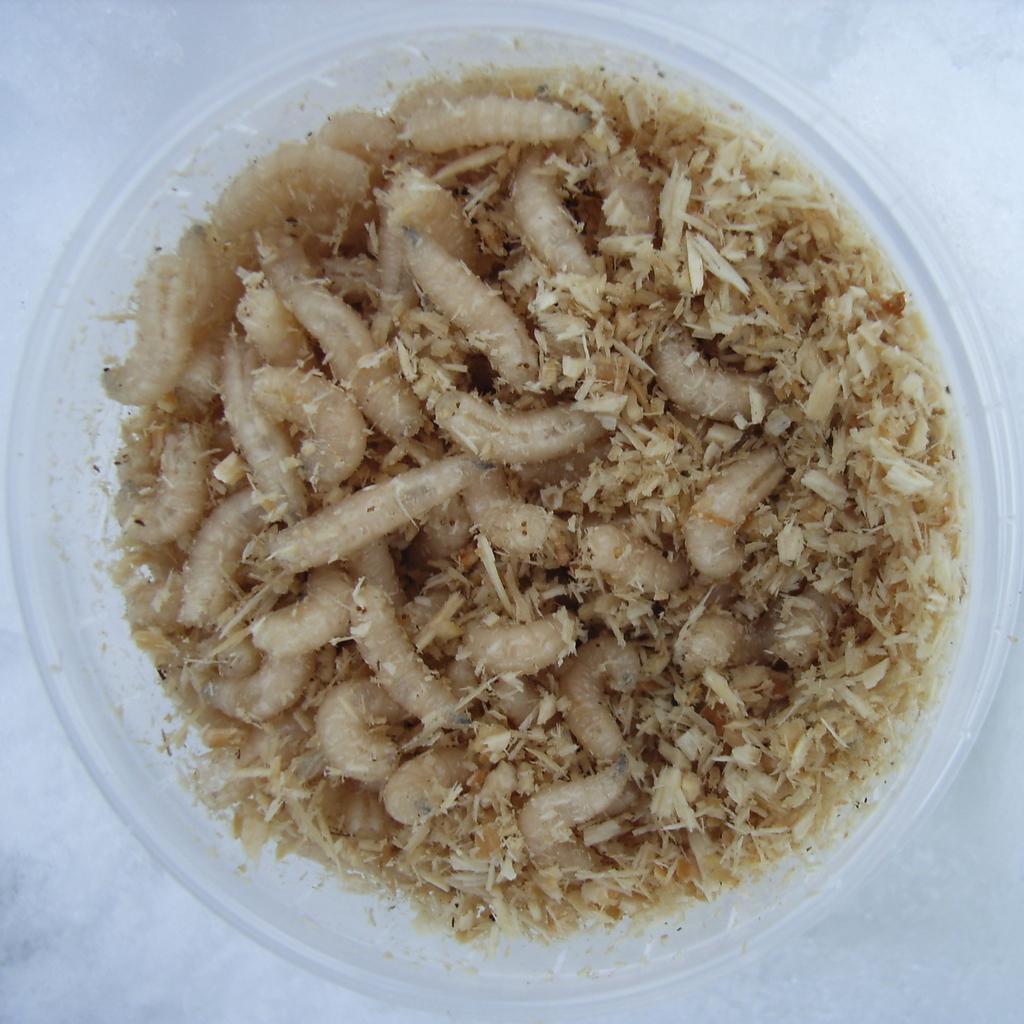Please provide a concise description of this image. In the foreground of this image, there are worms in a bowl. 